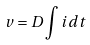Convert formula to latex. <formula><loc_0><loc_0><loc_500><loc_500>v = D \int i d t</formula> 